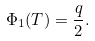Convert formula to latex. <formula><loc_0><loc_0><loc_500><loc_500>\Phi _ { 1 } ( T ) = \frac { q } { 2 } .</formula> 